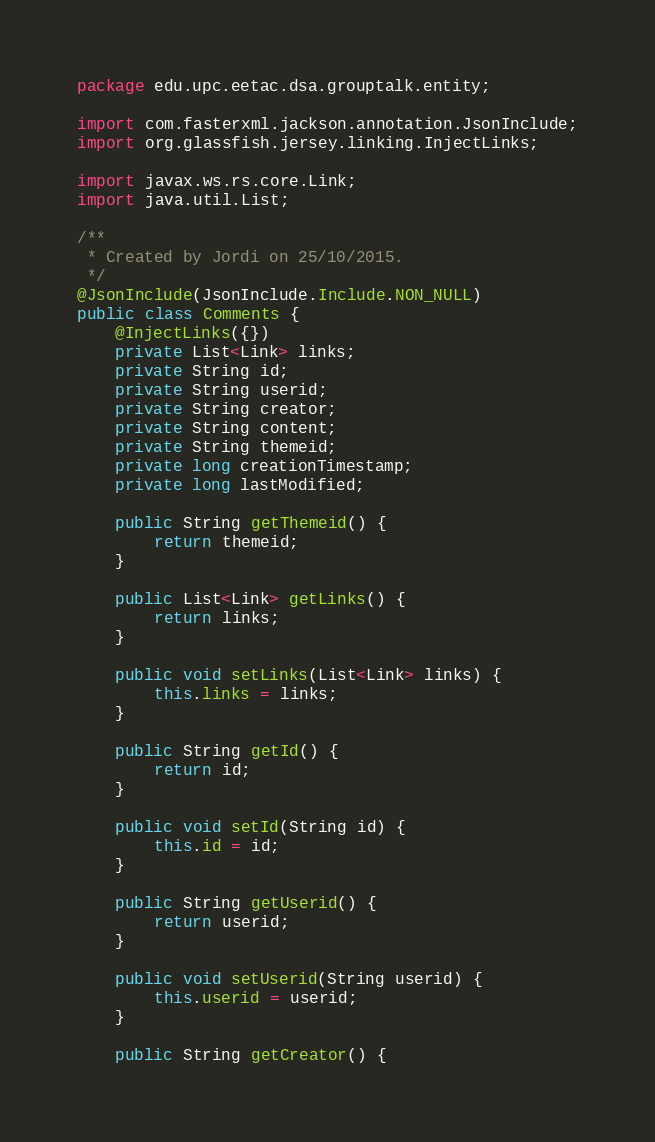Convert code to text. <code><loc_0><loc_0><loc_500><loc_500><_Java_>package edu.upc.eetac.dsa.grouptalk.entity;

import com.fasterxml.jackson.annotation.JsonInclude;
import org.glassfish.jersey.linking.InjectLinks;

import javax.ws.rs.core.Link;
import java.util.List;

/**
 * Created by Jordi on 25/10/2015.
 */
@JsonInclude(JsonInclude.Include.NON_NULL)
public class Comments {
    @InjectLinks({})
    private List<Link> links;
    private String id;
    private String userid;
    private String creator;
    private String content;
    private String themeid;
    private long creationTimestamp;
    private long lastModified;

    public String getThemeid() {
        return themeid;
    }

    public List<Link> getLinks() {
        return links;
    }

    public void setLinks(List<Link> links) {
        this.links = links;
    }

    public String getId() {
        return id;
    }

    public void setId(String id) {
        this.id = id;
    }

    public String getUserid() {
        return userid;
    }

    public void setUserid(String userid) {
        this.userid = userid;
    }

    public String getCreator() {</code> 